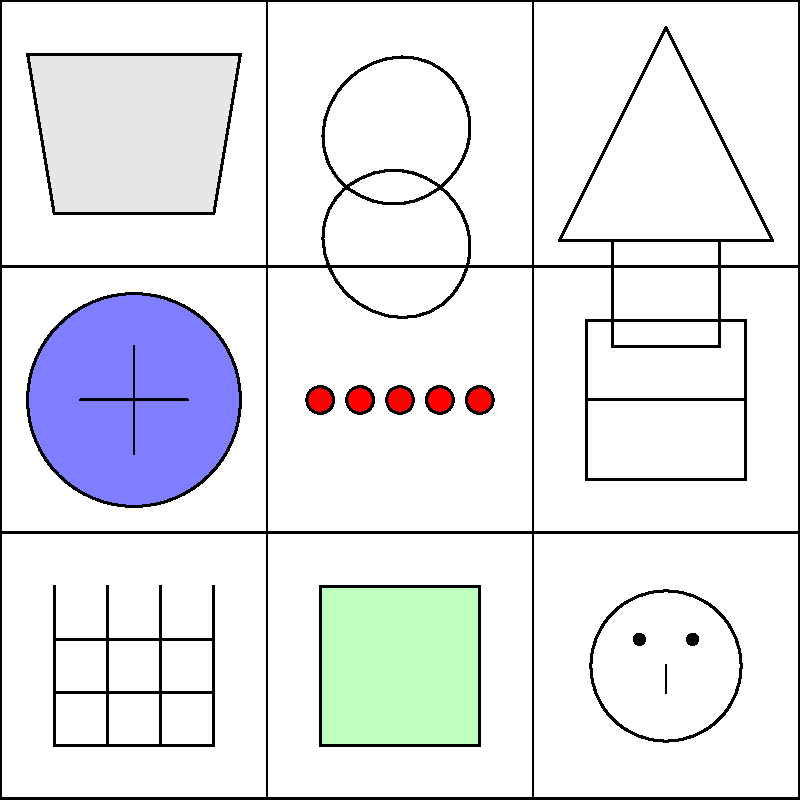In this grid of close-up images showcasing local crafts and artisanal products, how many items are typically associated with wearing or adorning the body? Let's analyze each item in the grid to determine which are typically associated with wearing or adorning the body:

1. Top-left: Pottery - Not worn on the body
2. Top-center: Woven basket - Not worn on the body
3. Top-right: Carved wooden figurine - Not worn on the body
4. Middle-left: Hand-painted ceramic plate - Not worn on the body
5. Middle-center: Beaded jewelry - Worn on the body
6. Middle-right: Traditional musical instrument - Not worn on the body
7. Bottom-left: Hand-woven textile - Can be worn on the body (e.g., as clothing or scarf)
8. Bottom-center: Locally made soap - Not worn on the body
9. Bottom-right: Traditional mask - Worn on the body (face)

Counting the items typically associated with wearing or adorning the body:
1. Beaded jewelry
2. Hand-woven textile
3. Traditional mask

Therefore, there are 3 items in the grid that are typically associated with wearing or adorning the body.
Answer: 3 